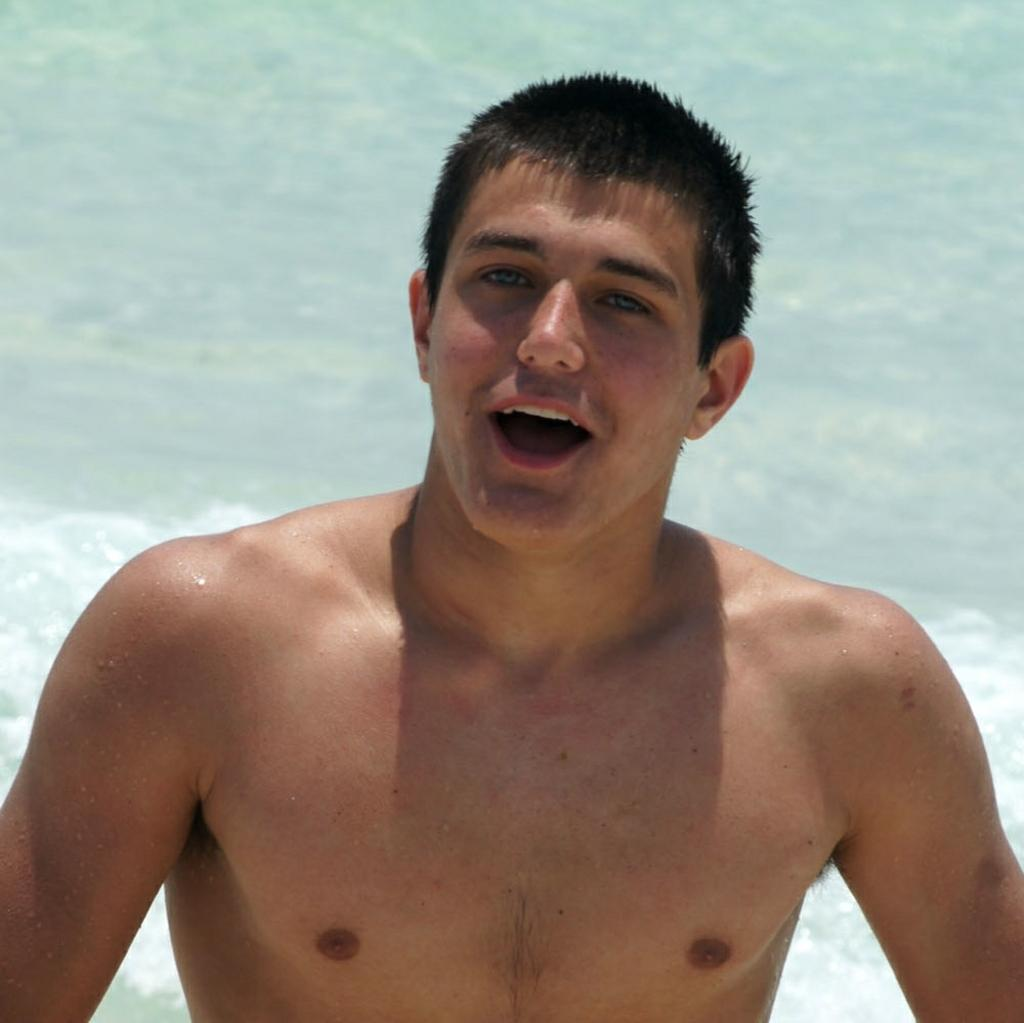What is present in the image? There is a person in the image. Can you describe the background of the image? There is water visible in the background of the image. What type of wire is being used by the person in the image? There is no wire present in the image. Is the person holding a rifle in the image? There is no rifle present in the image. 